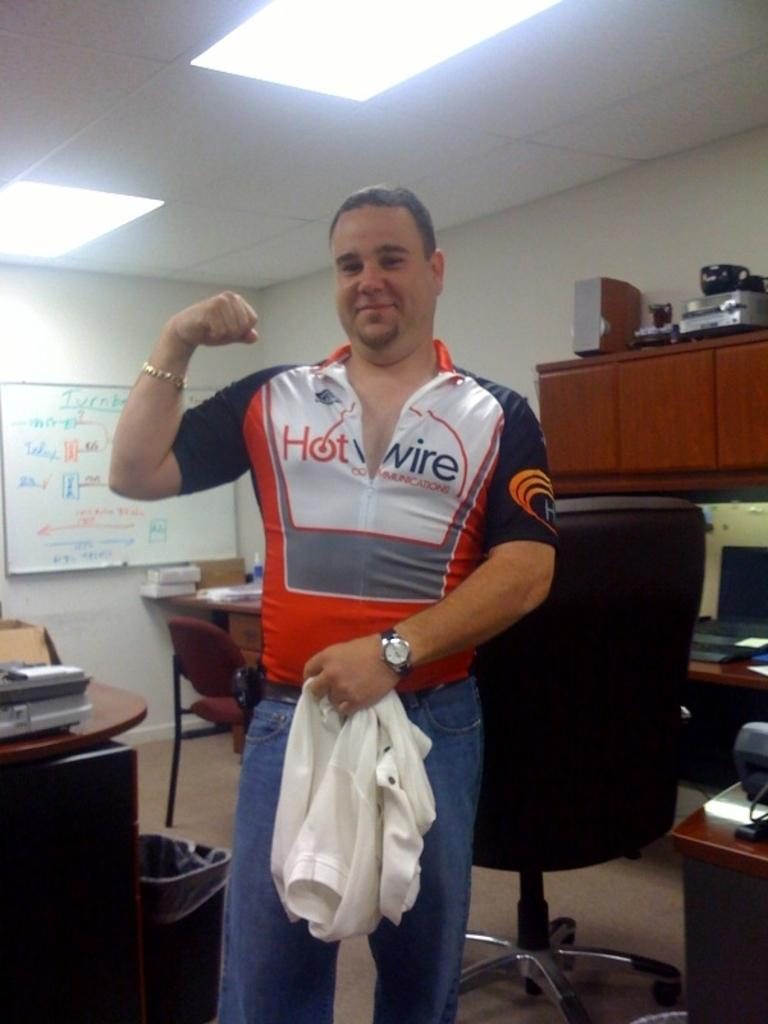<image>
Offer a succinct explanation of the picture presented. A man poses for a photo wearing a Hot Wire jersey 